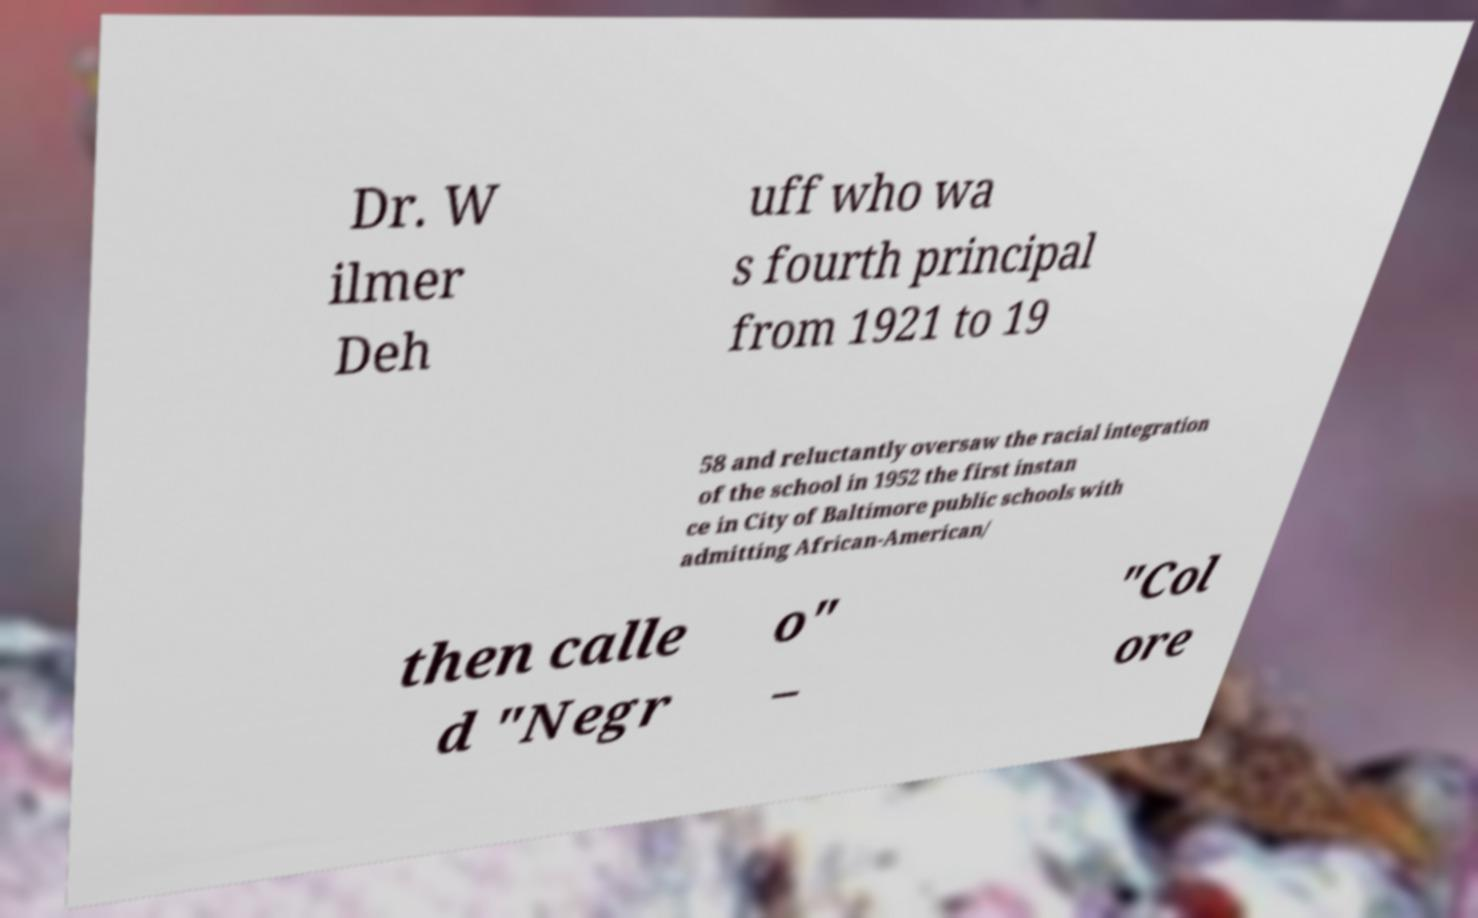Please identify and transcribe the text found in this image. Dr. W ilmer Deh uff who wa s fourth principal from 1921 to 19 58 and reluctantly oversaw the racial integration of the school in 1952 the first instan ce in City of Baltimore public schools with admitting African-American/ then calle d "Negr o" – "Col ore 